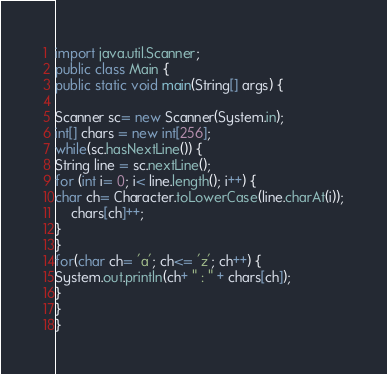<code> <loc_0><loc_0><loc_500><loc_500><_Java_>import java.util.Scanner;
public class Main {
public static void main(String[] args) {

Scanner sc= new Scanner(System.in);
int[] chars = new int[256];
while(sc.hasNextLine()) {
String line = sc.nextLine();
for (int i= 0; i< line.length(); i++) {
char ch= Character.toLowerCase(line.charAt(i));
	chars[ch]++;
}
}
for(char ch= 'a'; ch<= 'z'; ch++) {
System.out.println(ch+ " : " + chars[ch]);
}
}
}</code> 